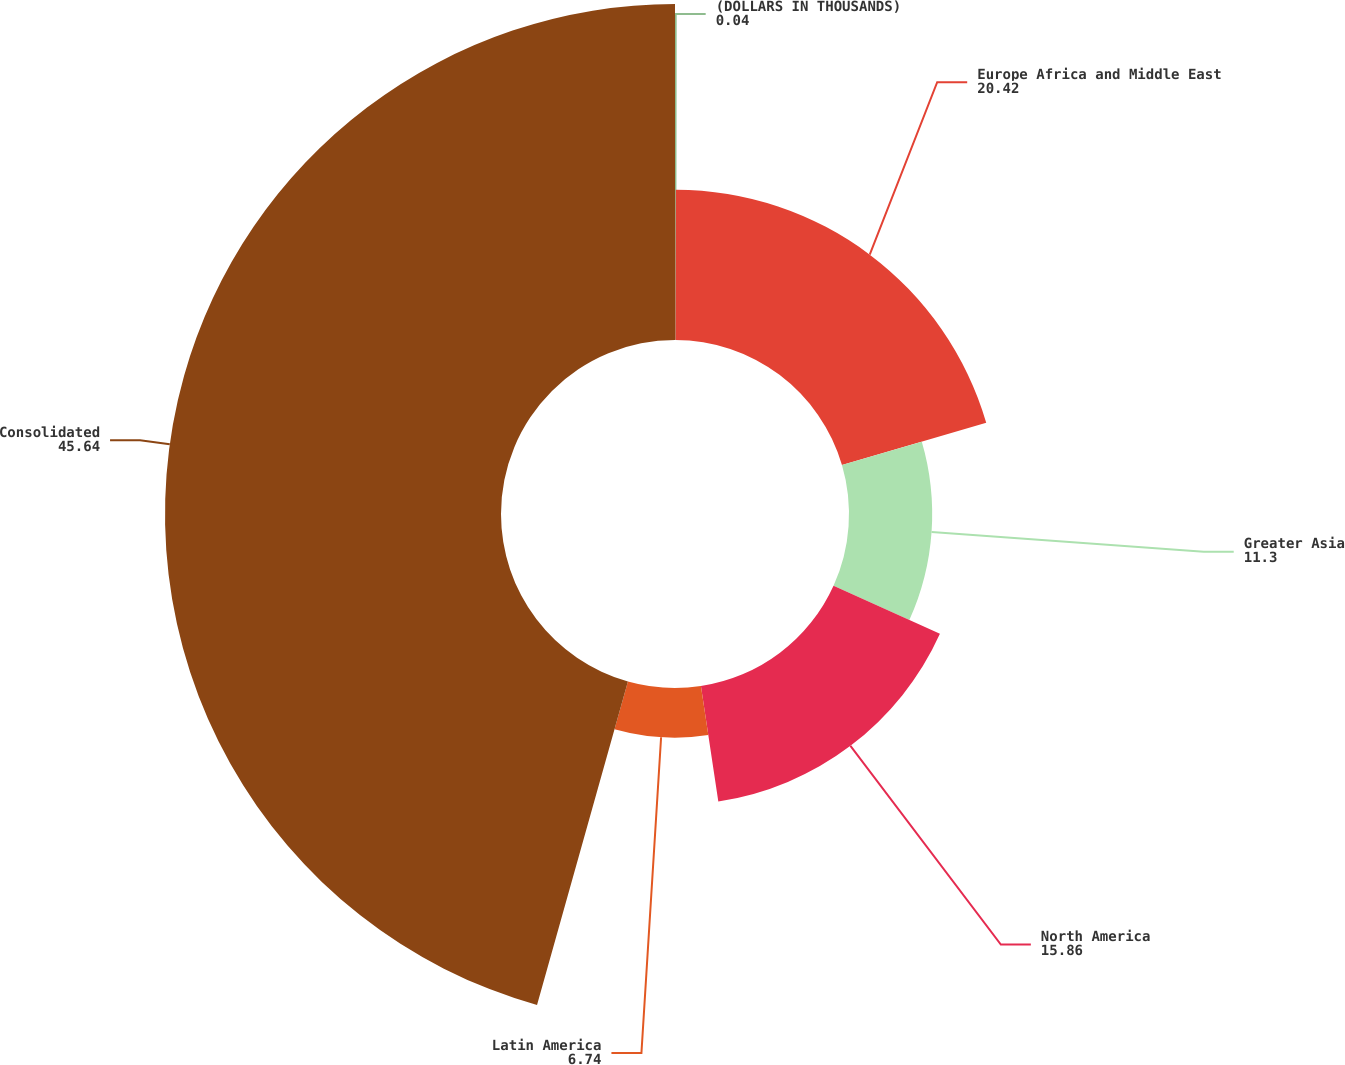Convert chart to OTSL. <chart><loc_0><loc_0><loc_500><loc_500><pie_chart><fcel>(DOLLARS IN THOUSANDS)<fcel>Europe Africa and Middle East<fcel>Greater Asia<fcel>North America<fcel>Latin America<fcel>Consolidated<nl><fcel>0.04%<fcel>20.42%<fcel>11.3%<fcel>15.86%<fcel>6.74%<fcel>45.64%<nl></chart> 